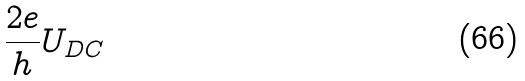Convert formula to latex. <formula><loc_0><loc_0><loc_500><loc_500>\frac { 2 e } { h } U _ { D C }</formula> 